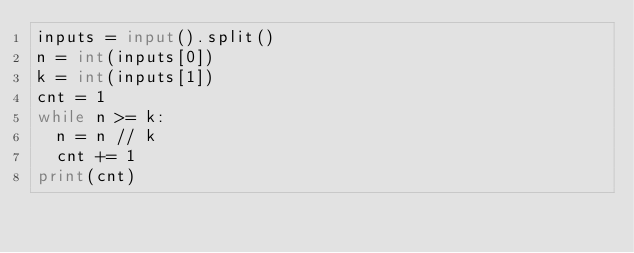<code> <loc_0><loc_0><loc_500><loc_500><_Python_>inputs = input().split()
n = int(inputs[0])
k = int(inputs[1])
cnt = 1
while n >= k:
  n = n // k
  cnt += 1
print(cnt)</code> 